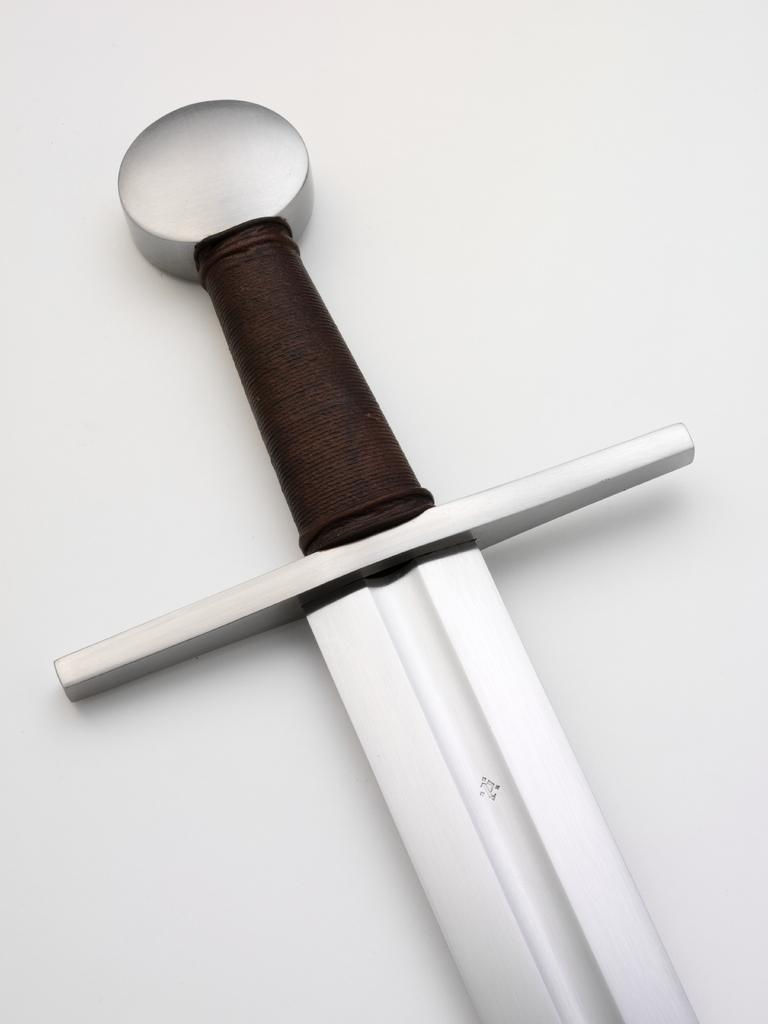What object is present in the image that resembles a weapon? There is a sword in the image. What is the color of the handle of the sword? The sword has a black handle. What advice does the mom give to the performer on stage in the image? There is no mom, performer, or stage present in the image; it only features a sword with a black handle. 